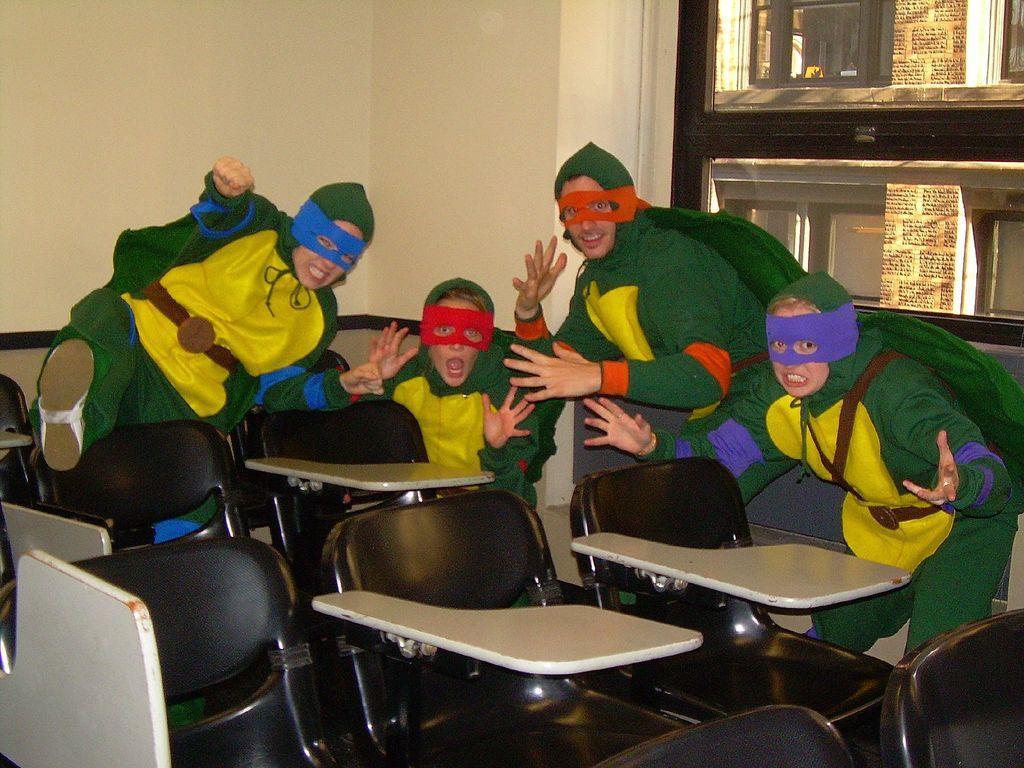Could you give a brief overview of what you see in this image? There are some children and a man in this room, wearing costumes and masks on their faces, sitting in the chairs. In the background there is a wall. 